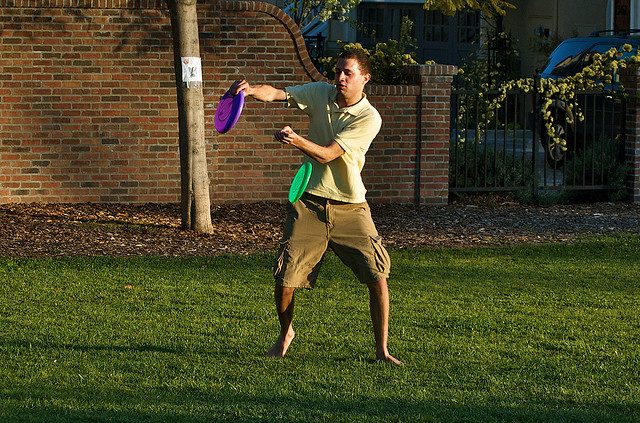<image>What are those yellow objects in the court? It is unknown what the yellow objects in the court are. They could be flowers, leaves, or a man's shirt. What are those yellow objects in the court? I am not sure what those yellow objects in the court are. It can be seen flowers or leaves. 